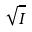Convert formula to latex. <formula><loc_0><loc_0><loc_500><loc_500>\sqrt { I }</formula> 